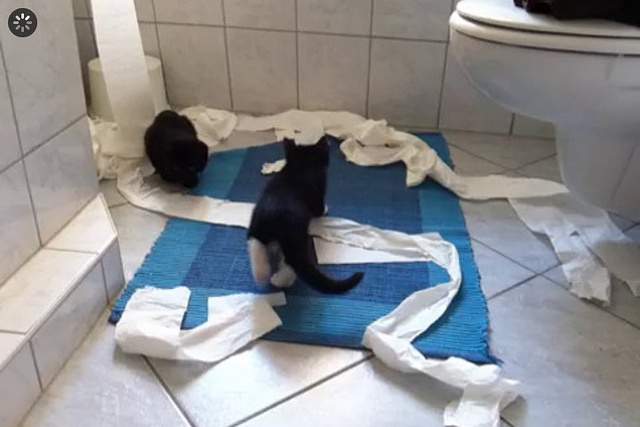Describe the objects in this image and their specific colors. I can see toilet in darkgray and gray tones, cat in darkgray, black, and gray tones, and cat in darkgray, black, gray, and darkblue tones in this image. 